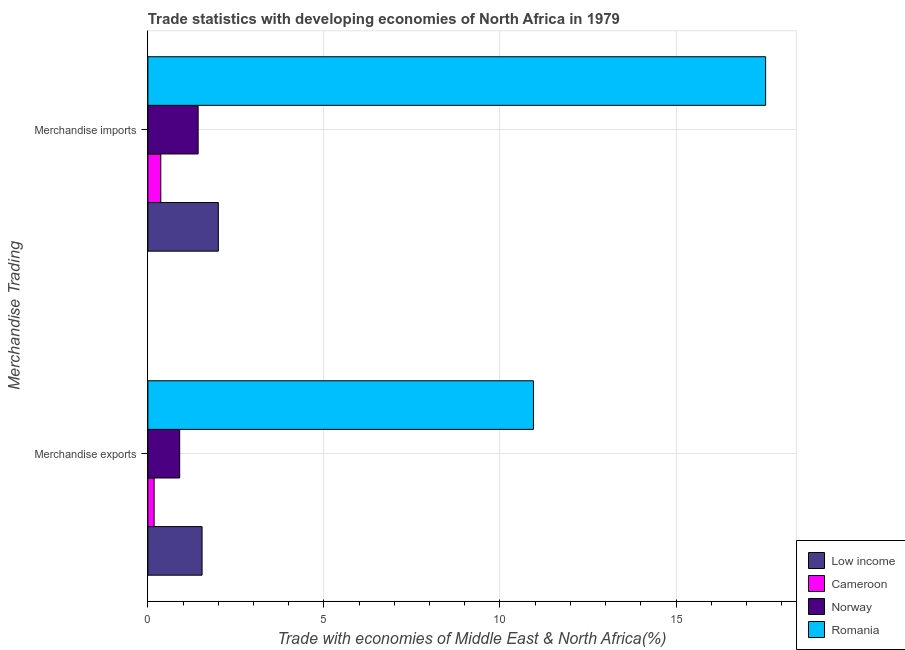How many groups of bars are there?
Your answer should be compact. 2. Are the number of bars per tick equal to the number of legend labels?
Give a very brief answer. Yes. How many bars are there on the 1st tick from the top?
Make the answer very short. 4. What is the label of the 1st group of bars from the top?
Your response must be concise. Merchandise imports. What is the merchandise exports in Romania?
Make the answer very short. 10.95. Across all countries, what is the maximum merchandise exports?
Provide a succinct answer. 10.95. Across all countries, what is the minimum merchandise exports?
Give a very brief answer. 0.18. In which country was the merchandise exports maximum?
Provide a succinct answer. Romania. In which country was the merchandise exports minimum?
Keep it short and to the point. Cameroon. What is the total merchandise exports in the graph?
Offer a terse response. 13.57. What is the difference between the merchandise exports in Cameroon and that in Romania?
Make the answer very short. -10.77. What is the difference between the merchandise imports in Norway and the merchandise exports in Cameroon?
Offer a terse response. 1.25. What is the average merchandise exports per country?
Your answer should be compact. 3.39. What is the difference between the merchandise imports and merchandise exports in Norway?
Offer a very short reply. 0.52. What is the ratio of the merchandise exports in Low income to that in Norway?
Make the answer very short. 1.7. Is the merchandise imports in Romania less than that in Norway?
Make the answer very short. No. In how many countries, is the merchandise exports greater than the average merchandise exports taken over all countries?
Provide a succinct answer. 1. What does the 1st bar from the top in Merchandise imports represents?
Offer a very short reply. Romania. How many countries are there in the graph?
Offer a terse response. 4. What is the difference between two consecutive major ticks on the X-axis?
Provide a succinct answer. 5. Are the values on the major ticks of X-axis written in scientific E-notation?
Your answer should be very brief. No. Does the graph contain any zero values?
Give a very brief answer. No. Does the graph contain grids?
Provide a short and direct response. Yes. How many legend labels are there?
Give a very brief answer. 4. How are the legend labels stacked?
Ensure brevity in your answer.  Vertical. What is the title of the graph?
Give a very brief answer. Trade statistics with developing economies of North Africa in 1979. What is the label or title of the X-axis?
Keep it short and to the point. Trade with economies of Middle East & North Africa(%). What is the label or title of the Y-axis?
Provide a short and direct response. Merchandise Trading. What is the Trade with economies of Middle East & North Africa(%) of Low income in Merchandise exports?
Your response must be concise. 1.54. What is the Trade with economies of Middle East & North Africa(%) of Cameroon in Merchandise exports?
Offer a very short reply. 0.18. What is the Trade with economies of Middle East & North Africa(%) of Norway in Merchandise exports?
Make the answer very short. 0.9. What is the Trade with economies of Middle East & North Africa(%) in Romania in Merchandise exports?
Provide a short and direct response. 10.95. What is the Trade with economies of Middle East & North Africa(%) in Low income in Merchandise imports?
Provide a short and direct response. 2. What is the Trade with economies of Middle East & North Africa(%) in Cameroon in Merchandise imports?
Give a very brief answer. 0.37. What is the Trade with economies of Middle East & North Africa(%) of Norway in Merchandise imports?
Keep it short and to the point. 1.43. What is the Trade with economies of Middle East & North Africa(%) in Romania in Merchandise imports?
Your answer should be compact. 17.54. Across all Merchandise Trading, what is the maximum Trade with economies of Middle East & North Africa(%) in Low income?
Keep it short and to the point. 2. Across all Merchandise Trading, what is the maximum Trade with economies of Middle East & North Africa(%) of Cameroon?
Ensure brevity in your answer.  0.37. Across all Merchandise Trading, what is the maximum Trade with economies of Middle East & North Africa(%) in Norway?
Offer a terse response. 1.43. Across all Merchandise Trading, what is the maximum Trade with economies of Middle East & North Africa(%) in Romania?
Keep it short and to the point. 17.54. Across all Merchandise Trading, what is the minimum Trade with economies of Middle East & North Africa(%) in Low income?
Your response must be concise. 1.54. Across all Merchandise Trading, what is the minimum Trade with economies of Middle East & North Africa(%) of Cameroon?
Keep it short and to the point. 0.18. Across all Merchandise Trading, what is the minimum Trade with economies of Middle East & North Africa(%) in Norway?
Ensure brevity in your answer.  0.9. Across all Merchandise Trading, what is the minimum Trade with economies of Middle East & North Africa(%) of Romania?
Your answer should be very brief. 10.95. What is the total Trade with economies of Middle East & North Africa(%) of Low income in the graph?
Ensure brevity in your answer.  3.54. What is the total Trade with economies of Middle East & North Africa(%) of Cameroon in the graph?
Offer a very short reply. 0.55. What is the total Trade with economies of Middle East & North Africa(%) of Norway in the graph?
Make the answer very short. 2.33. What is the total Trade with economies of Middle East & North Africa(%) of Romania in the graph?
Make the answer very short. 28.49. What is the difference between the Trade with economies of Middle East & North Africa(%) in Low income in Merchandise exports and that in Merchandise imports?
Offer a terse response. -0.46. What is the difference between the Trade with economies of Middle East & North Africa(%) of Cameroon in Merchandise exports and that in Merchandise imports?
Offer a very short reply. -0.19. What is the difference between the Trade with economies of Middle East & North Africa(%) of Norway in Merchandise exports and that in Merchandise imports?
Your response must be concise. -0.52. What is the difference between the Trade with economies of Middle East & North Africa(%) in Romania in Merchandise exports and that in Merchandise imports?
Your response must be concise. -6.59. What is the difference between the Trade with economies of Middle East & North Africa(%) of Low income in Merchandise exports and the Trade with economies of Middle East & North Africa(%) of Cameroon in Merchandise imports?
Ensure brevity in your answer.  1.17. What is the difference between the Trade with economies of Middle East & North Africa(%) in Low income in Merchandise exports and the Trade with economies of Middle East & North Africa(%) in Norway in Merchandise imports?
Offer a very short reply. 0.11. What is the difference between the Trade with economies of Middle East & North Africa(%) in Low income in Merchandise exports and the Trade with economies of Middle East & North Africa(%) in Romania in Merchandise imports?
Make the answer very short. -16. What is the difference between the Trade with economies of Middle East & North Africa(%) in Cameroon in Merchandise exports and the Trade with economies of Middle East & North Africa(%) in Norway in Merchandise imports?
Provide a short and direct response. -1.25. What is the difference between the Trade with economies of Middle East & North Africa(%) in Cameroon in Merchandise exports and the Trade with economies of Middle East & North Africa(%) in Romania in Merchandise imports?
Ensure brevity in your answer.  -17.37. What is the difference between the Trade with economies of Middle East & North Africa(%) in Norway in Merchandise exports and the Trade with economies of Middle East & North Africa(%) in Romania in Merchandise imports?
Offer a terse response. -16.64. What is the average Trade with economies of Middle East & North Africa(%) in Low income per Merchandise Trading?
Give a very brief answer. 1.77. What is the average Trade with economies of Middle East & North Africa(%) in Cameroon per Merchandise Trading?
Ensure brevity in your answer.  0.27. What is the average Trade with economies of Middle East & North Africa(%) in Norway per Merchandise Trading?
Your answer should be very brief. 1.17. What is the average Trade with economies of Middle East & North Africa(%) in Romania per Merchandise Trading?
Provide a succinct answer. 14.25. What is the difference between the Trade with economies of Middle East & North Africa(%) of Low income and Trade with economies of Middle East & North Africa(%) of Cameroon in Merchandise exports?
Ensure brevity in your answer.  1.36. What is the difference between the Trade with economies of Middle East & North Africa(%) in Low income and Trade with economies of Middle East & North Africa(%) in Norway in Merchandise exports?
Your answer should be very brief. 0.64. What is the difference between the Trade with economies of Middle East & North Africa(%) in Low income and Trade with economies of Middle East & North Africa(%) in Romania in Merchandise exports?
Your answer should be very brief. -9.41. What is the difference between the Trade with economies of Middle East & North Africa(%) of Cameroon and Trade with economies of Middle East & North Africa(%) of Norway in Merchandise exports?
Keep it short and to the point. -0.73. What is the difference between the Trade with economies of Middle East & North Africa(%) of Cameroon and Trade with economies of Middle East & North Africa(%) of Romania in Merchandise exports?
Provide a short and direct response. -10.77. What is the difference between the Trade with economies of Middle East & North Africa(%) of Norway and Trade with economies of Middle East & North Africa(%) of Romania in Merchandise exports?
Make the answer very short. -10.05. What is the difference between the Trade with economies of Middle East & North Africa(%) in Low income and Trade with economies of Middle East & North Africa(%) in Cameroon in Merchandise imports?
Make the answer very short. 1.63. What is the difference between the Trade with economies of Middle East & North Africa(%) of Low income and Trade with economies of Middle East & North Africa(%) of Norway in Merchandise imports?
Offer a very short reply. 0.57. What is the difference between the Trade with economies of Middle East & North Africa(%) of Low income and Trade with economies of Middle East & North Africa(%) of Romania in Merchandise imports?
Your answer should be compact. -15.54. What is the difference between the Trade with economies of Middle East & North Africa(%) of Cameroon and Trade with economies of Middle East & North Africa(%) of Norway in Merchandise imports?
Provide a succinct answer. -1.06. What is the difference between the Trade with economies of Middle East & North Africa(%) in Cameroon and Trade with economies of Middle East & North Africa(%) in Romania in Merchandise imports?
Offer a terse response. -17.18. What is the difference between the Trade with economies of Middle East & North Africa(%) in Norway and Trade with economies of Middle East & North Africa(%) in Romania in Merchandise imports?
Your answer should be compact. -16.12. What is the ratio of the Trade with economies of Middle East & North Africa(%) in Low income in Merchandise exports to that in Merchandise imports?
Offer a very short reply. 0.77. What is the ratio of the Trade with economies of Middle East & North Africa(%) of Cameroon in Merchandise exports to that in Merchandise imports?
Keep it short and to the point. 0.48. What is the ratio of the Trade with economies of Middle East & North Africa(%) of Norway in Merchandise exports to that in Merchandise imports?
Provide a succinct answer. 0.63. What is the ratio of the Trade with economies of Middle East & North Africa(%) in Romania in Merchandise exports to that in Merchandise imports?
Your answer should be compact. 0.62. What is the difference between the highest and the second highest Trade with economies of Middle East & North Africa(%) of Low income?
Keep it short and to the point. 0.46. What is the difference between the highest and the second highest Trade with economies of Middle East & North Africa(%) of Cameroon?
Keep it short and to the point. 0.19. What is the difference between the highest and the second highest Trade with economies of Middle East & North Africa(%) in Norway?
Offer a terse response. 0.52. What is the difference between the highest and the second highest Trade with economies of Middle East & North Africa(%) of Romania?
Make the answer very short. 6.59. What is the difference between the highest and the lowest Trade with economies of Middle East & North Africa(%) of Low income?
Your response must be concise. 0.46. What is the difference between the highest and the lowest Trade with economies of Middle East & North Africa(%) in Cameroon?
Make the answer very short. 0.19. What is the difference between the highest and the lowest Trade with economies of Middle East & North Africa(%) of Norway?
Offer a very short reply. 0.52. What is the difference between the highest and the lowest Trade with economies of Middle East & North Africa(%) of Romania?
Offer a terse response. 6.59. 